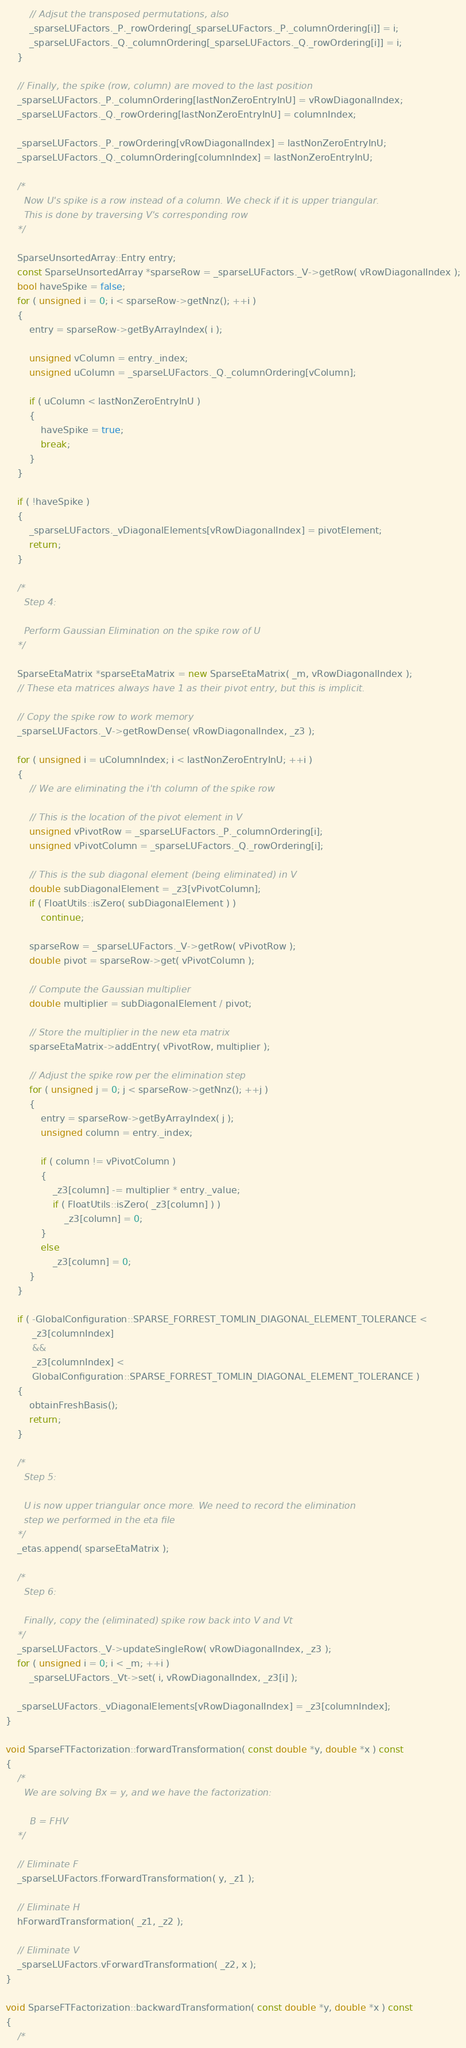Convert code to text. <code><loc_0><loc_0><loc_500><loc_500><_C++_>        // Adjsut the transposed permutations, also
        _sparseLUFactors._P._rowOrdering[_sparseLUFactors._P._columnOrdering[i]] = i;
        _sparseLUFactors._Q._columnOrdering[_sparseLUFactors._Q._rowOrdering[i]] = i;
    }

    // Finally, the spike (row, column) are moved to the last position
    _sparseLUFactors._P._columnOrdering[lastNonZeroEntryInU] = vRowDiagonalIndex;
    _sparseLUFactors._Q._rowOrdering[lastNonZeroEntryInU] = columnIndex;

    _sparseLUFactors._P._rowOrdering[vRowDiagonalIndex] = lastNonZeroEntryInU;
    _sparseLUFactors._Q._columnOrdering[columnIndex] = lastNonZeroEntryInU;

    /*
      Now U's spike is a row instead of a column. We check if it is upper triangular.
      This is done by traversing V's corresponding row
    */

    SparseUnsortedArray::Entry entry;
    const SparseUnsortedArray *sparseRow = _sparseLUFactors._V->getRow( vRowDiagonalIndex );
    bool haveSpike = false;
    for ( unsigned i = 0; i < sparseRow->getNnz(); ++i )
    {
        entry = sparseRow->getByArrayIndex( i );

        unsigned vColumn = entry._index;
        unsigned uColumn = _sparseLUFactors._Q._columnOrdering[vColumn];

        if ( uColumn < lastNonZeroEntryInU )
        {
            haveSpike = true;
            break;
        }
    }

    if ( !haveSpike )
    {
        _sparseLUFactors._vDiagonalElements[vRowDiagonalIndex] = pivotElement;
        return;
    }

    /*
      Step 4:

      Perform Gaussian Elimination on the spike row of U
    */

    SparseEtaMatrix *sparseEtaMatrix = new SparseEtaMatrix( _m, vRowDiagonalIndex );
    // These eta matrices always have 1 as their pivot entry, but this is implicit.

    // Copy the spike row to work memory
    _sparseLUFactors._V->getRowDense( vRowDiagonalIndex, _z3 );

    for ( unsigned i = uColumnIndex; i < lastNonZeroEntryInU; ++i )
    {
        // We are eliminating the i'th column of the spike row

        // This is the location of the pivot element in V
        unsigned vPivotRow = _sparseLUFactors._P._columnOrdering[i];
        unsigned vPivotColumn = _sparseLUFactors._Q._rowOrdering[i];

        // This is the sub diagonal element (being eliminated) in V
        double subDiagonalElement = _z3[vPivotColumn];
        if ( FloatUtils::isZero( subDiagonalElement ) )
            continue;

        sparseRow = _sparseLUFactors._V->getRow( vPivotRow );
        double pivot = sparseRow->get( vPivotColumn );

        // Compute the Gaussian multiplier
        double multiplier = subDiagonalElement / pivot;

        // Store the multiplier in the new eta matrix
        sparseEtaMatrix->addEntry( vPivotRow, multiplier );

        // Adjust the spike row per the elimination step
        for ( unsigned j = 0; j < sparseRow->getNnz(); ++j )
        {
            entry = sparseRow->getByArrayIndex( j );
            unsigned column = entry._index;

            if ( column != vPivotColumn )
            {
                _z3[column] -= multiplier * entry._value;
                if ( FloatUtils::isZero( _z3[column] ) )
                    _z3[column] = 0;
            }
            else
                _z3[column] = 0;
        }
    }

    if ( -GlobalConfiguration::SPARSE_FORREST_TOMLIN_DIAGONAL_ELEMENT_TOLERANCE <
         _z3[columnIndex]
         &&
         _z3[columnIndex] <
         GlobalConfiguration::SPARSE_FORREST_TOMLIN_DIAGONAL_ELEMENT_TOLERANCE )
    {
        obtainFreshBasis();
        return;
    }

    /*
      Step 5:

      U is now upper triangular once more. We need to record the elimination
      step we performed in the eta file
    */
    _etas.append( sparseEtaMatrix );

    /*
      Step 6:

      Finally, copy the (eliminated) spike row back into V and Vt
    */
    _sparseLUFactors._V->updateSingleRow( vRowDiagonalIndex, _z3 );
    for ( unsigned i = 0; i < _m; ++i )
        _sparseLUFactors._Vt->set( i, vRowDiagonalIndex, _z3[i] );

    _sparseLUFactors._vDiagonalElements[vRowDiagonalIndex] = _z3[columnIndex];
}

void SparseFTFactorization::forwardTransformation( const double *y, double *x ) const
{
    /*
      We are solving Bx = y, and we have the factorization:

        B = FHV
    */

    // Eliminate F
    _sparseLUFactors.fForwardTransformation( y, _z1 );

    // Eliminate H
    hForwardTransformation( _z1, _z2 );

    // Eliminate V
    _sparseLUFactors.vForwardTransformation( _z2, x );
}

void SparseFTFactorization::backwardTransformation( const double *y, double *x ) const
{
    /*</code> 